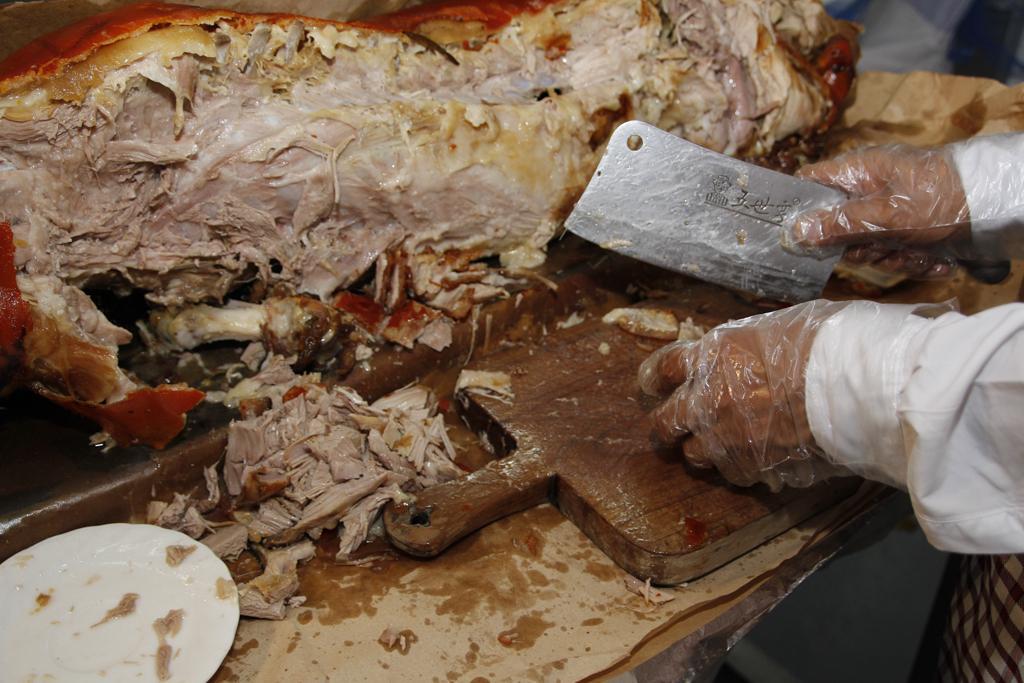How would you summarize this image in a sentence or two? In this picture I can see the person's hand who is a wiring plastic cover gloves and white dress. He is holding a knife and cutting the meat into pieces. On the table I can see the meat, plate and cutting pad. 